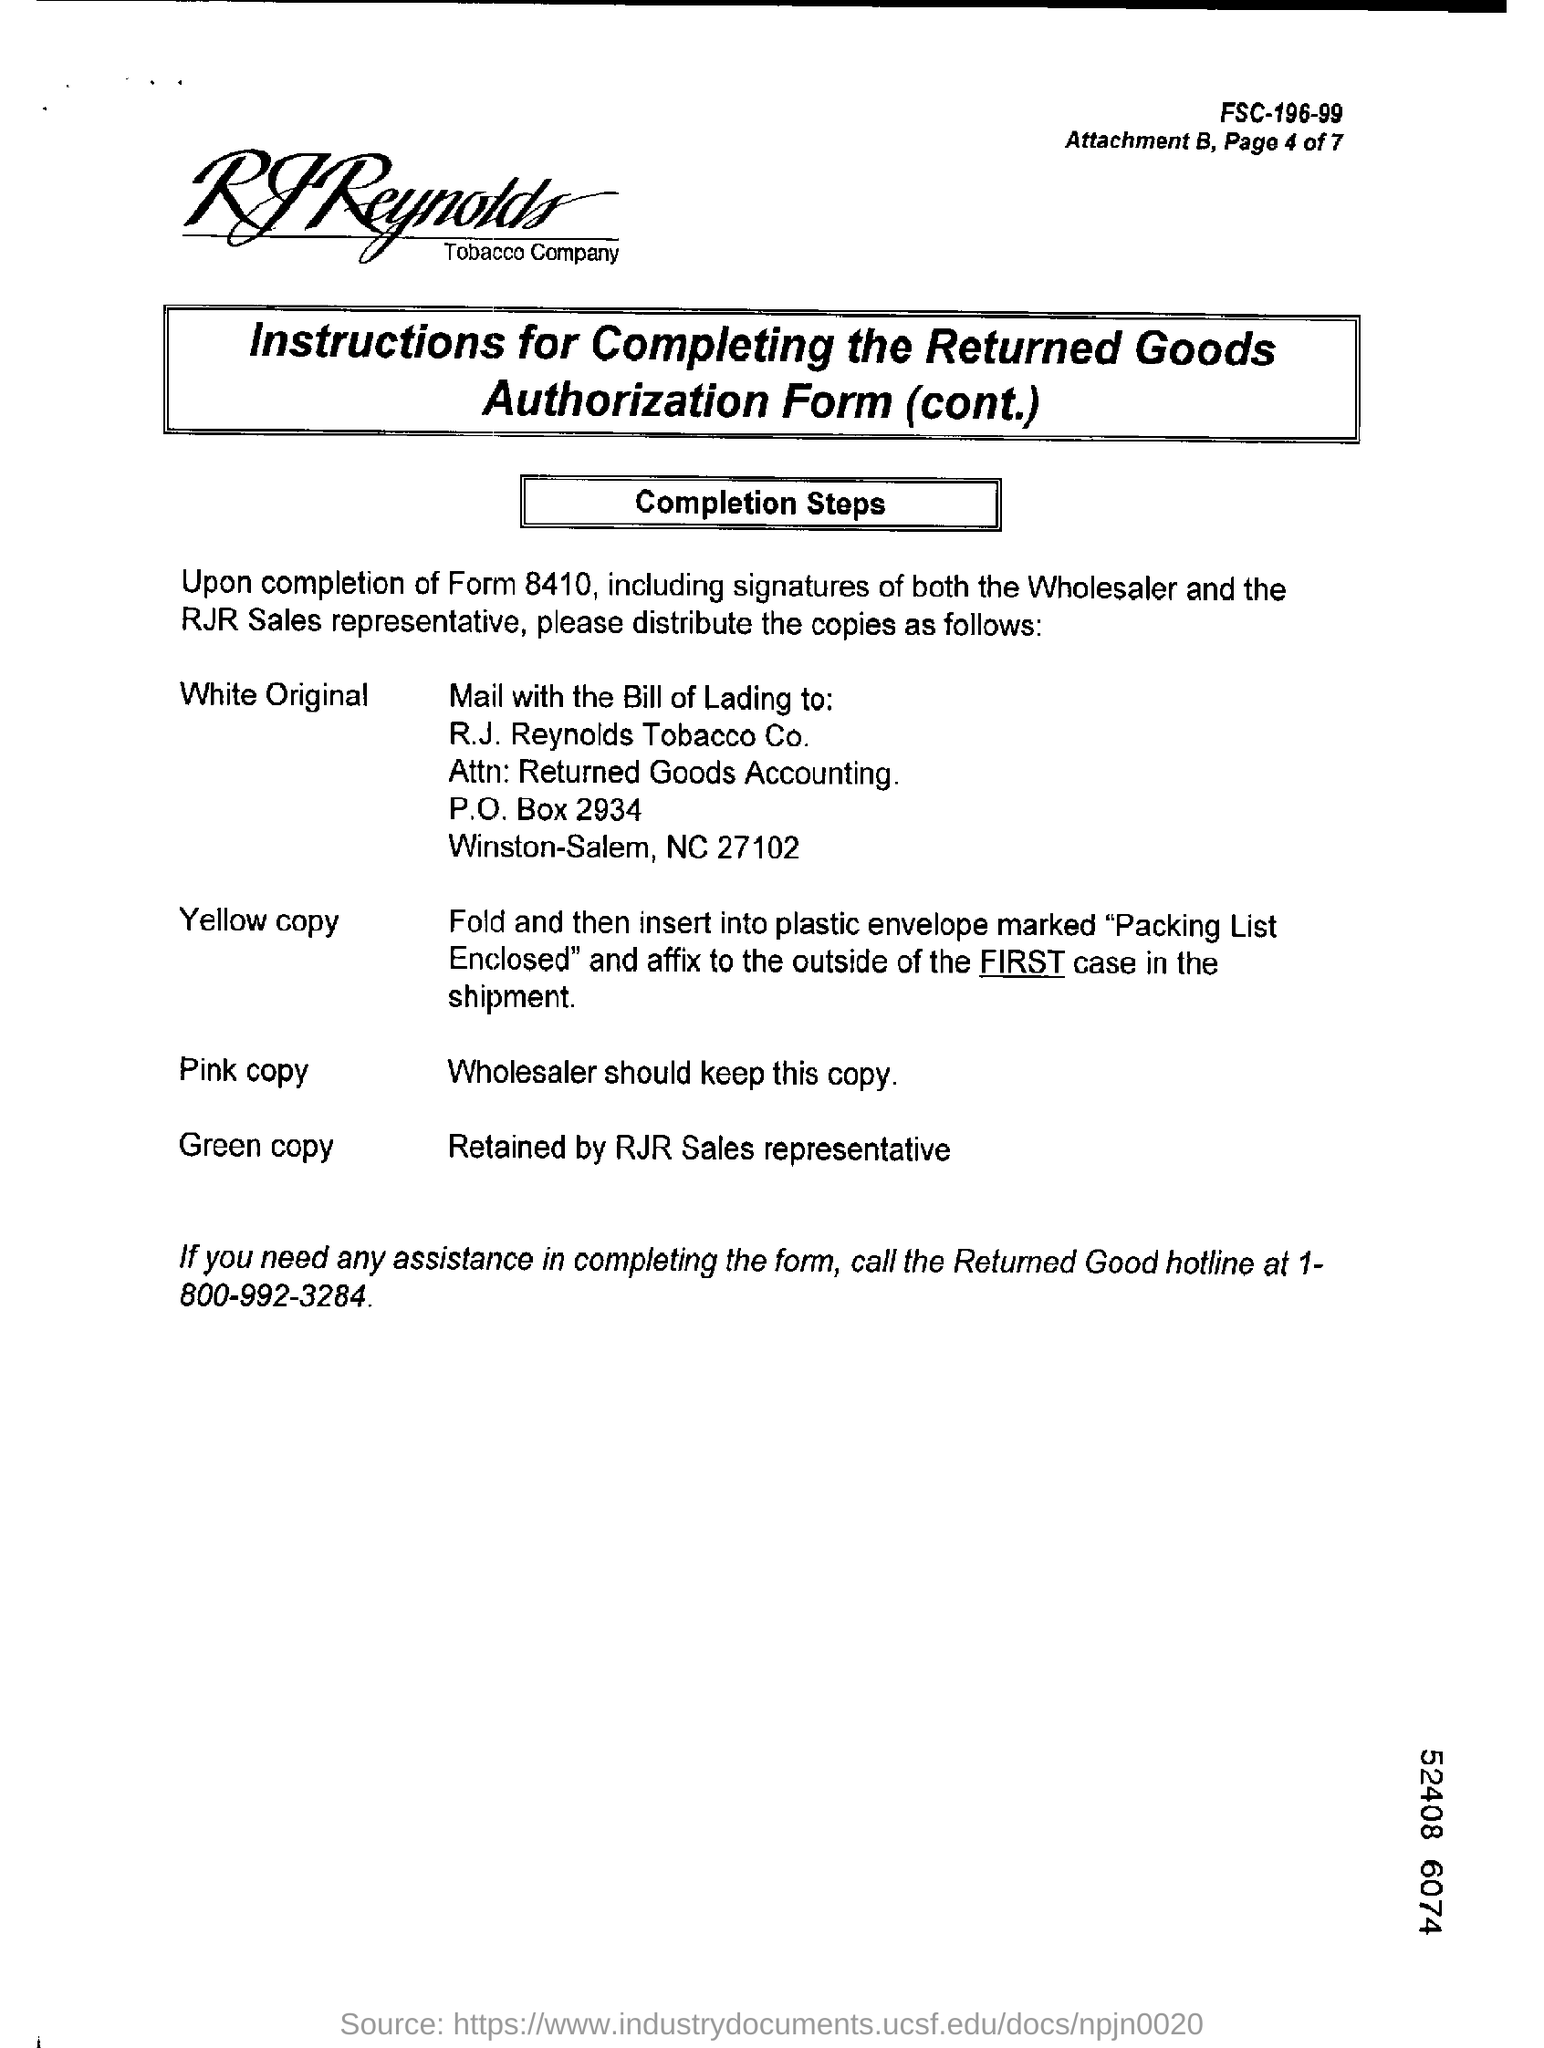What is the Returned good hotline number ?
Your answer should be very brief. 1-800-992-3284. 